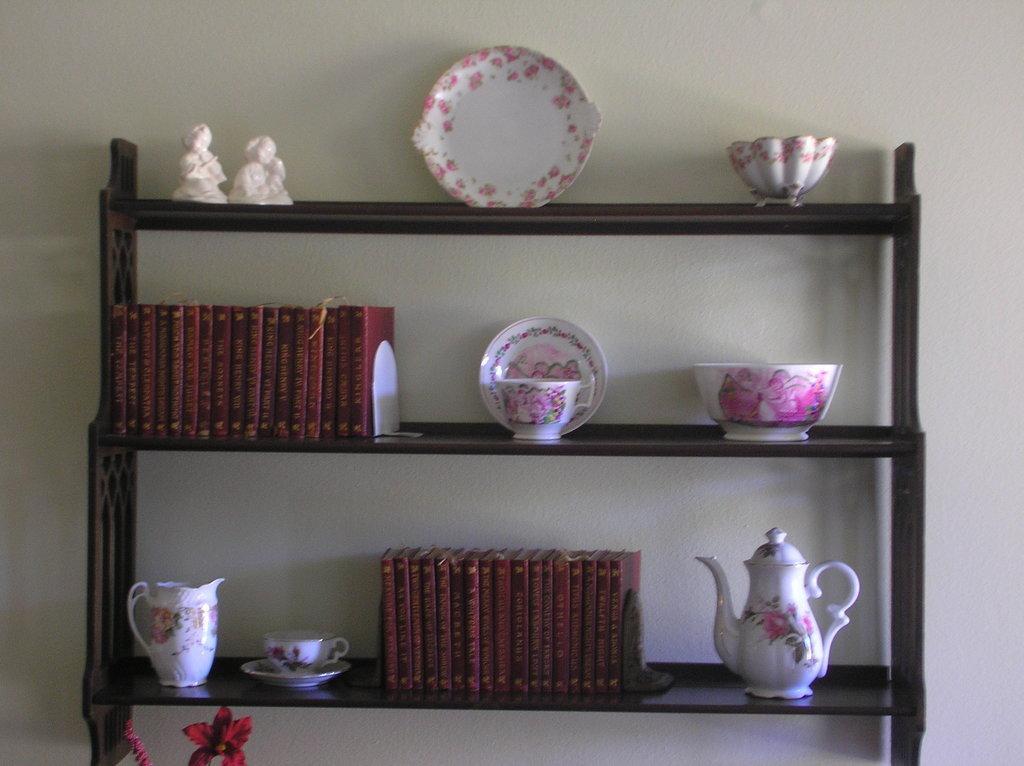How would you summarize this image in a sentence or two? In this image, we can see some shelves with objects like plates, bowls, jars, books and some mini statues. We can also see the wall. 